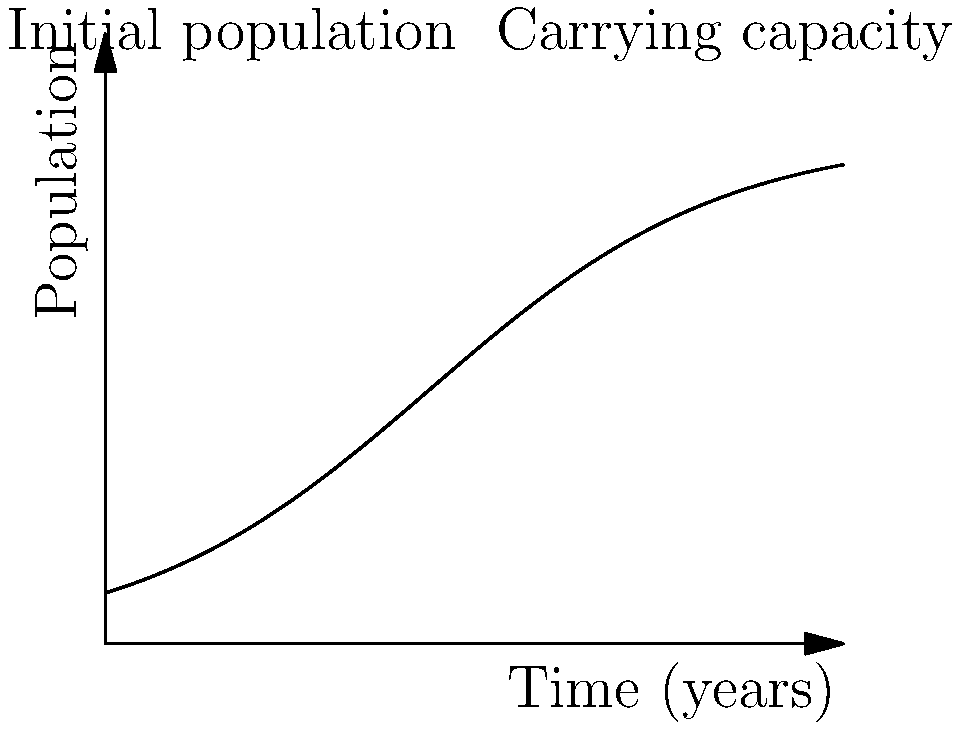A population of endangered species in a shrinking habitat due to cattle ranching follows a logistic growth model. The initial population is 100 individuals, and the carrying capacity of the habitat is 1000 individuals. The growth rate is 0.5 per year. Using the logistic growth model, calculate the population after 5 years. Round your answer to the nearest whole number. To solve this problem, we'll use the logistic growth model:

$$ P(t) = \frac{K}{1 + (\frac{K}{P_0} - 1)e^{-rt}} $$

Where:
$P(t)$ is the population at time $t$
$K$ is the carrying capacity
$P_0$ is the initial population
$r$ is the growth rate
$t$ is the time

Given:
$K = 1000$
$P_0 = 100$
$r = 0.5$
$t = 5$

Let's substitute these values into the equation:

$$ P(5) = \frac{1000}{1 + (\frac{1000}{100} - 1)e^{-0.5 \cdot 5}} $$

$$ = \frac{1000}{1 + (10 - 1)e^{-2.5}} $$

$$ = \frac{1000}{1 + 9e^{-2.5}} $$

Using a calculator:

$$ = \frac{1000}{1 + 9 \cdot 0.0821} $$

$$ = \frac{1000}{1 + 0.7389} $$

$$ = \frac{1000}{1.7389} $$

$$ \approx 574.79 $$

Rounding to the nearest whole number:

$P(5) \approx 575$
Answer: 575 individuals 